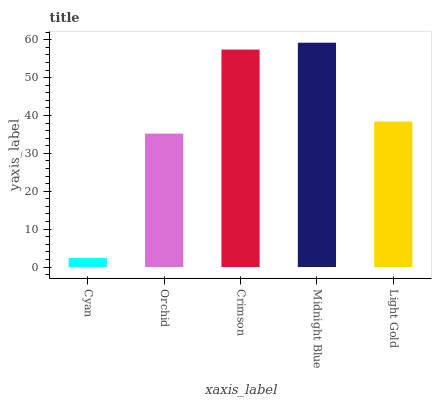Is Cyan the minimum?
Answer yes or no. Yes. Is Midnight Blue the maximum?
Answer yes or no. Yes. Is Orchid the minimum?
Answer yes or no. No. Is Orchid the maximum?
Answer yes or no. No. Is Orchid greater than Cyan?
Answer yes or no. Yes. Is Cyan less than Orchid?
Answer yes or no. Yes. Is Cyan greater than Orchid?
Answer yes or no. No. Is Orchid less than Cyan?
Answer yes or no. No. Is Light Gold the high median?
Answer yes or no. Yes. Is Light Gold the low median?
Answer yes or no. Yes. Is Orchid the high median?
Answer yes or no. No. Is Orchid the low median?
Answer yes or no. No. 